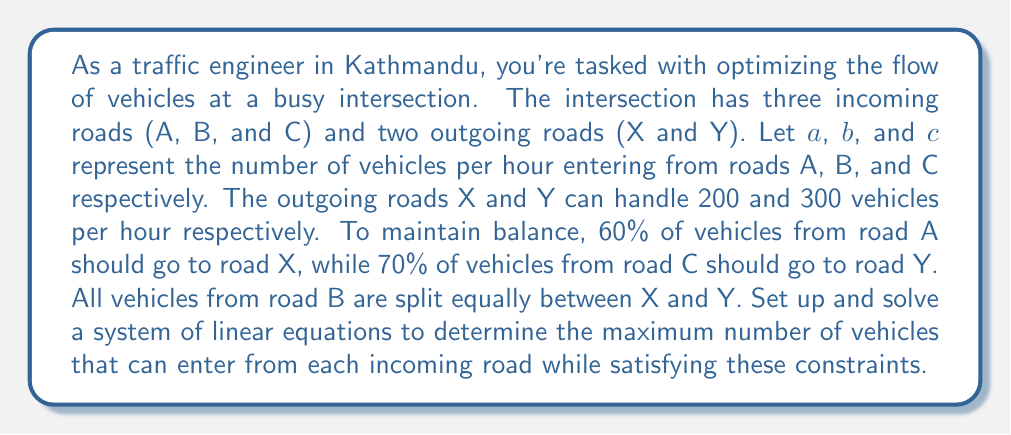What is the answer to this math problem? Let's approach this step-by-step:

1) First, let's set up our equations based on the given information:

   For road X: $0.6a + 0.5b + 0.3c = 200$ (Equation 1)
   For road Y: $0.4a + 0.5b + 0.7c = 300$ (Equation 2)

2) We also know that the total number of vehicles entering must equal the total number exiting:

   $a + b + c = 200 + 300 = 500$ (Equation 3)

3) Now we have a system of three linear equations with three unknowns. Let's solve this system using substitution.

4) From Equation 3, we can express $c$ in terms of $a$ and $b$:
   $c = 500 - a - b$

5) Substituting this into Equation 1:
   $0.6a + 0.5b + 0.3(500 - a - b) = 200$
   $0.6a + 0.5b + 150 - 0.3a - 0.3b = 200$
   $0.3a + 0.2b = 50$ (Equation 4)

6) Similarly, substituting into Equation 2:
   $0.4a + 0.5b + 0.7(500 - a - b) = 300$
   $0.4a + 0.5b + 350 - 0.7a - 0.7b = 300$
   $-0.3a - 0.2b = -50$ (Equation 5)

7) Adding Equation 4 and Equation 5:
   $0.3a + 0.2b + (-0.3a - 0.2b) = 50 + (-50)$
   $0 = 0$

   This means our equations are dependent, and we have infinite solutions.

8) To find the maximum flow, we need to maximize $a$, $b$, and $c$ while satisfying our constraints.

9) From Equation 4: $a = \frac{50 - 0.2b}{0.3} = \frac{500 - 2b}{3}$

10) Substituting this into Equation 3:
    $\frac{500 - 2b}{3} + b + c = 500$
    $500 - 2b + 3b + 3c = 1500$
    $b + c = 333.33$

11) To maximize flow, we should maximize $b$ and $c$. Given the constraints, the optimal solution is:
    $b = 166.67$
    $c = 166.67$
    $a = \frac{500 - 2(166.67)}{3} = 166.67$
Answer: $a = 166.67$, $b = 166.67$, $c = 166.67$ vehicles per hour 